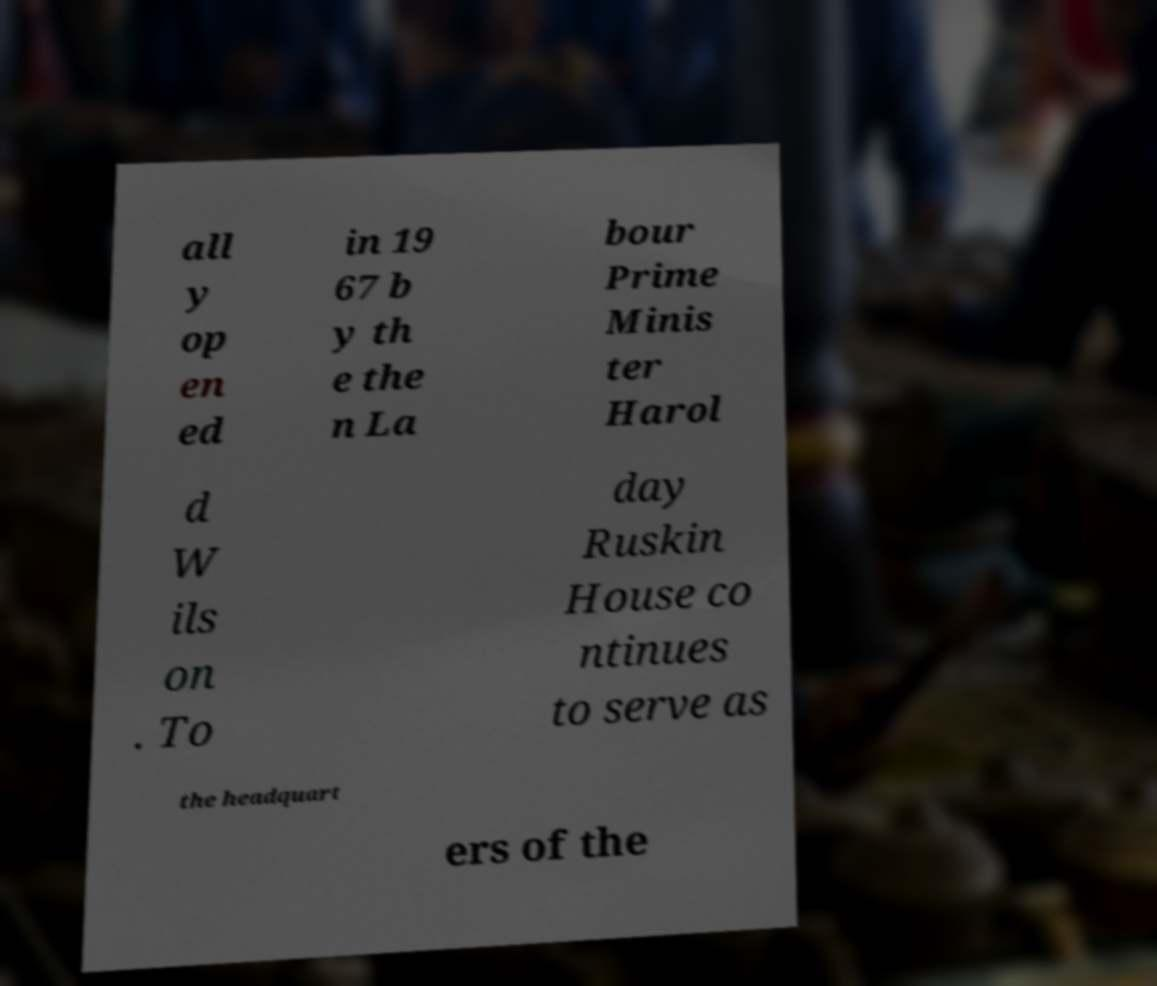Can you accurately transcribe the text from the provided image for me? all y op en ed in 19 67 b y th e the n La bour Prime Minis ter Harol d W ils on . To day Ruskin House co ntinues to serve as the headquart ers of the 